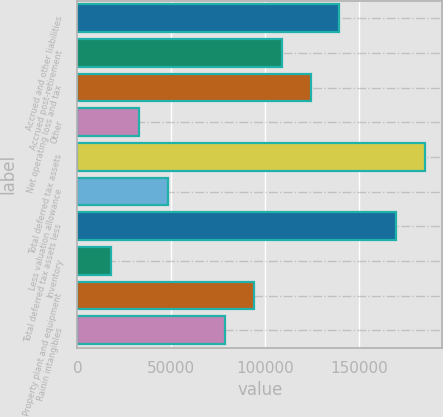Convert chart. <chart><loc_0><loc_0><loc_500><loc_500><bar_chart><fcel>Accrued and other liabilities<fcel>Accrued post-retirement<fcel>Net operating loss and tax<fcel>Other<fcel>Total deferred tax assets<fcel>Less valuation allowance<fcel>Total deferred tax assets less<fcel>Inventory<fcel>Property plant and equipment<fcel>Rainin intangibles<nl><fcel>139321<fcel>108934<fcel>124127<fcel>32964.6<fcel>184903<fcel>48158.4<fcel>169709<fcel>17770.8<fcel>93739.8<fcel>78546<nl></chart> 